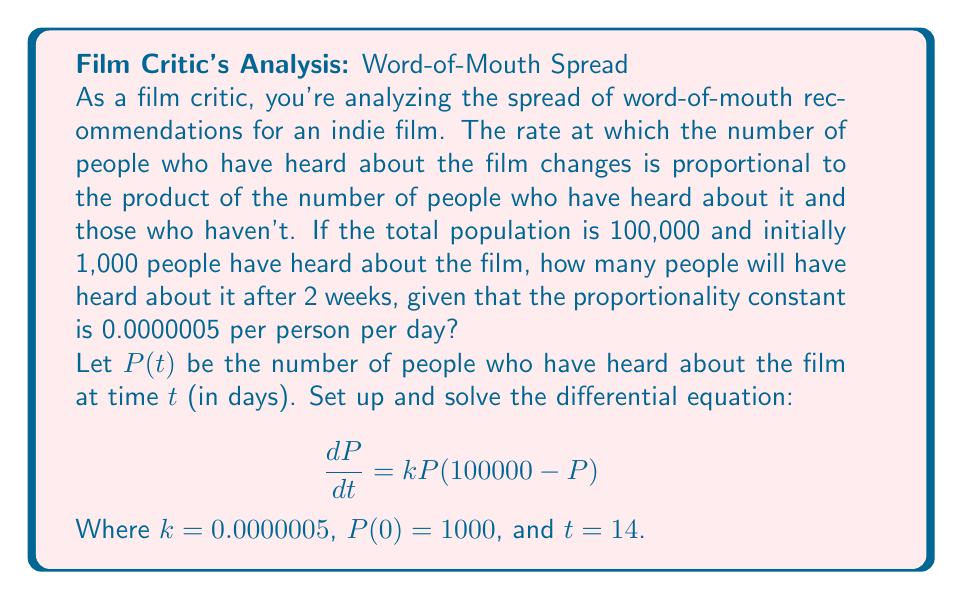Help me with this question. Let's solve this step-by-step:

1) We have the differential equation:
   $$\frac{dP}{dt} = kP(100000 - P)$$

2) This is a separable equation. Let's separate the variables:
   $$\frac{dP}{P(100000 - P)} = kdt$$

3) Integrate both sides:
   $$\int \frac{dP}{P(100000 - P)} = \int kdt$$

4) The left side can be integrated using partial fractions:
   $$\frac{1}{100000}\ln|P| - \frac{1}{100000}\ln|100000-P| = kt + C$$

5) Apply the initial condition $P(0) = 1000$:
   $$\frac{1}{100000}\ln|1000| - \frac{1}{100000}\ln|99000| = C$$

6) Subtract this from the general solution:
   $$\frac{1}{100000}\ln|\frac{P}{1000}| - \frac{1}{100000}\ln|\frac{100000-P}{99000}| = kt$$

7) Simplify:
   $$\ln|\frac{P}{1000}| - \ln|\frac{100000-P}{99000}| = 100000kt$$

8) Apply the exponential function to both sides:
   $$\frac{P}{1000} \cdot \frac{99000}{100000-P} = e^{100000kt}$$

9) Solve for P:
   $$P = \frac{100000}{1 + 99e^{-100000kt}}$$

10) Now, substitute $k = 0.0000005$ and $t = 14$:
    $$P = \frac{100000}{1 + 99e^{-0.7}}$$

11) Calculate the final result:
    $$P \approx 33,496.64$$
Answer: 33,497 people (rounded to the nearest whole person) 